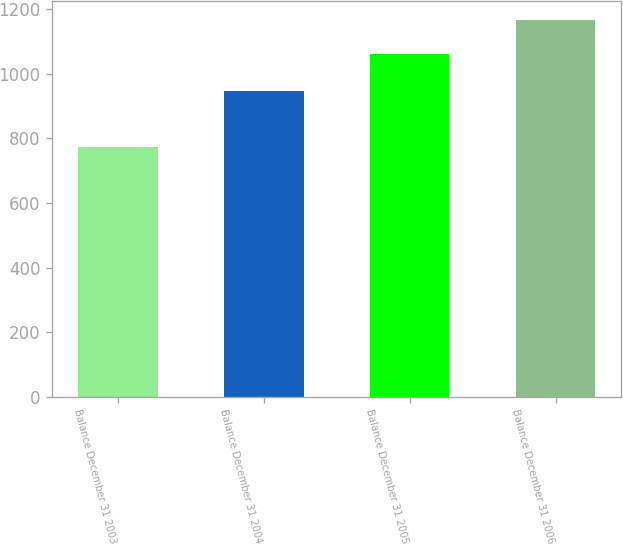<chart> <loc_0><loc_0><loc_500><loc_500><bar_chart><fcel>Balance December 31 2003<fcel>Balance December 31 2004<fcel>Balance December 31 2005<fcel>Balance December 31 2006<nl><fcel>774.6<fcel>945.6<fcel>1062.2<fcel>1166.4<nl></chart> 